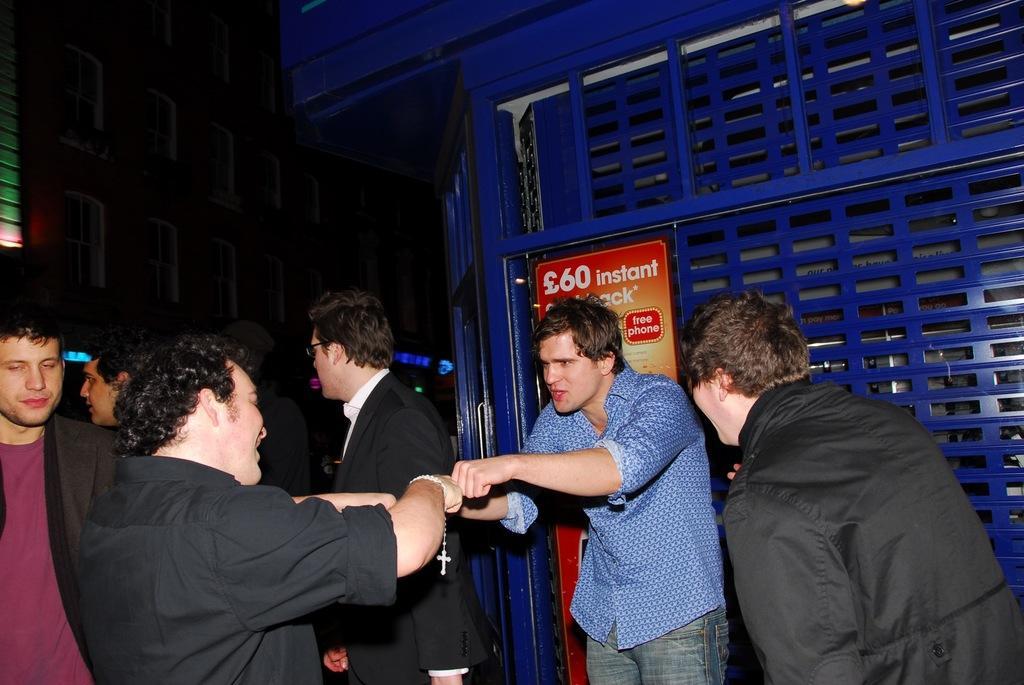Could you give a brief overview of what you see in this image? In this image in the front of there are persons standing. In the background there are objects which are black and blue in colour and there is a board with some text written on it. 